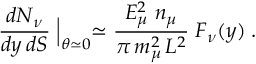Convert formula to latex. <formula><loc_0><loc_0><loc_500><loc_500>{ \frac { d N _ { \nu } } { d y \, d S } } \Big | _ { \theta \simeq 0 } \simeq { \frac { E _ { \mu } ^ { 2 } \, n _ { \mu } } { \pi \, m _ { \mu } ^ { 2 } \, L ^ { 2 } } } \, F _ { \nu } ( y ) \, .</formula> 